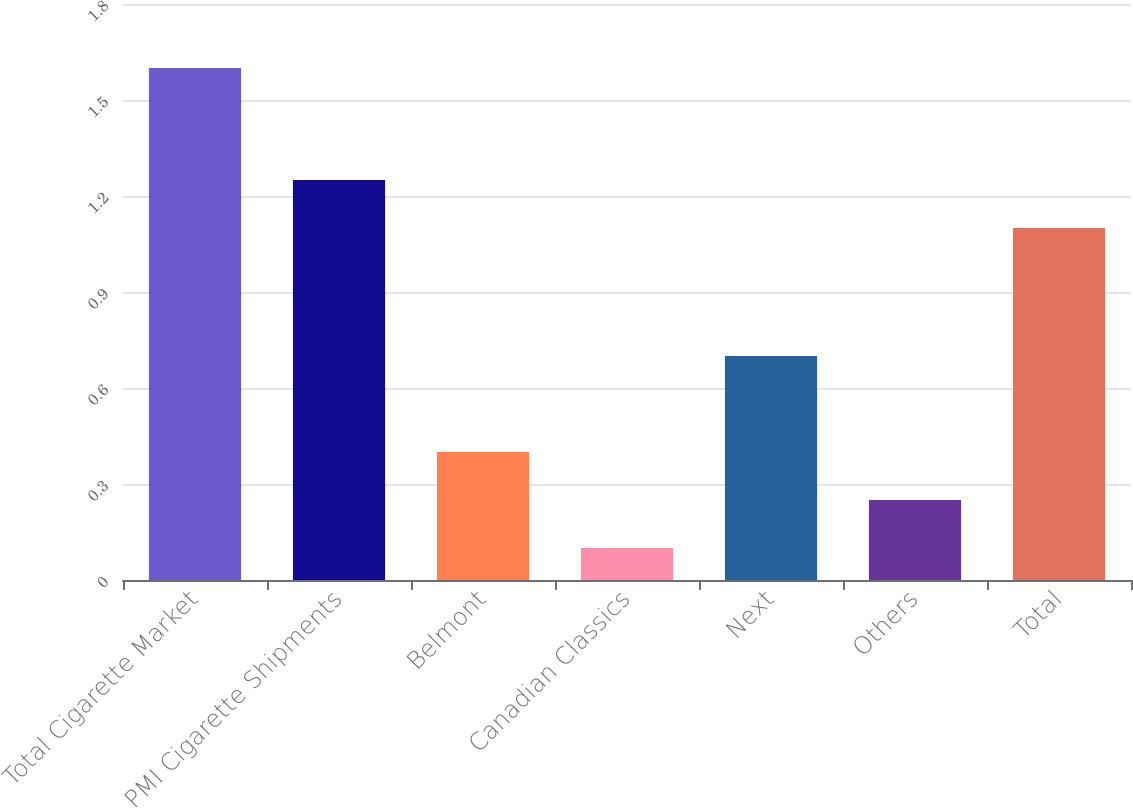Convert chart. <chart><loc_0><loc_0><loc_500><loc_500><bar_chart><fcel>Total Cigarette Market<fcel>PMI Cigarette Shipments<fcel>Belmont<fcel>Canadian Classics<fcel>Next<fcel>Others<fcel>Total<nl><fcel>1.6<fcel>1.25<fcel>0.4<fcel>0.1<fcel>0.7<fcel>0.25<fcel>1.1<nl></chart> 